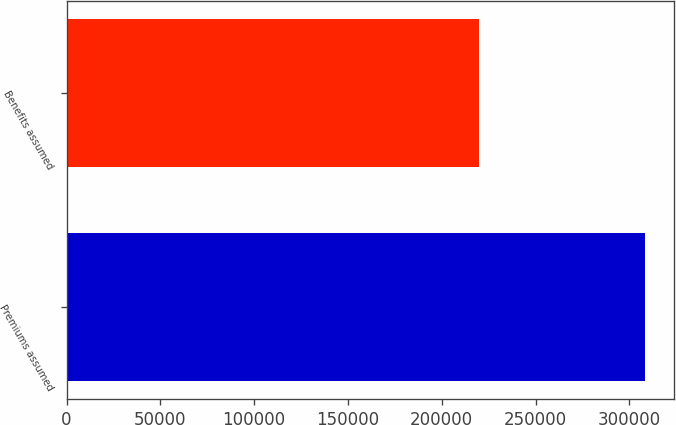Convert chart to OTSL. <chart><loc_0><loc_0><loc_500><loc_500><bar_chart><fcel>Premiums assumed<fcel>Benefits assumed<nl><fcel>308432<fcel>219665<nl></chart> 